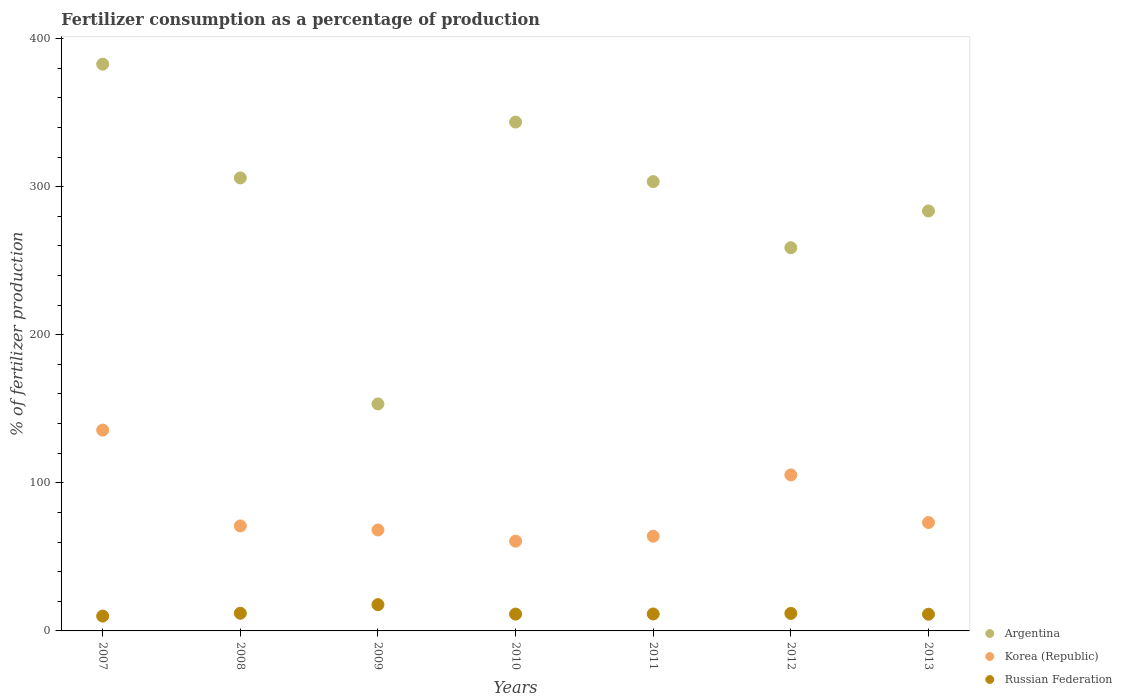How many different coloured dotlines are there?
Your response must be concise. 3. Is the number of dotlines equal to the number of legend labels?
Your answer should be compact. Yes. What is the percentage of fertilizers consumed in Argentina in 2010?
Offer a very short reply. 343.59. Across all years, what is the maximum percentage of fertilizers consumed in Russian Federation?
Offer a very short reply. 17.74. Across all years, what is the minimum percentage of fertilizers consumed in Russian Federation?
Your answer should be very brief. 10.02. In which year was the percentage of fertilizers consumed in Argentina minimum?
Keep it short and to the point. 2009. What is the total percentage of fertilizers consumed in Argentina in the graph?
Keep it short and to the point. 2031.15. What is the difference between the percentage of fertilizers consumed in Argentina in 2010 and that in 2013?
Offer a very short reply. 60. What is the difference between the percentage of fertilizers consumed in Korea (Republic) in 2011 and the percentage of fertilizers consumed in Russian Federation in 2008?
Make the answer very short. 52.02. What is the average percentage of fertilizers consumed in Korea (Republic) per year?
Keep it short and to the point. 82.53. In the year 2009, what is the difference between the percentage of fertilizers consumed in Korea (Republic) and percentage of fertilizers consumed in Argentina?
Give a very brief answer. -85.12. What is the ratio of the percentage of fertilizers consumed in Russian Federation in 2009 to that in 2010?
Provide a short and direct response. 1.56. Is the difference between the percentage of fertilizers consumed in Korea (Republic) in 2008 and 2013 greater than the difference between the percentage of fertilizers consumed in Argentina in 2008 and 2013?
Your answer should be compact. No. What is the difference between the highest and the second highest percentage of fertilizers consumed in Russian Federation?
Give a very brief answer. 5.81. What is the difference between the highest and the lowest percentage of fertilizers consumed in Korea (Republic)?
Your response must be concise. 74.99. Does the percentage of fertilizers consumed in Russian Federation monotonically increase over the years?
Your answer should be very brief. No. Is the percentage of fertilizers consumed in Korea (Republic) strictly greater than the percentage of fertilizers consumed in Argentina over the years?
Your answer should be very brief. No. Is the percentage of fertilizers consumed in Korea (Republic) strictly less than the percentage of fertilizers consumed in Argentina over the years?
Provide a short and direct response. Yes. How many dotlines are there?
Offer a terse response. 3. How many years are there in the graph?
Offer a terse response. 7. What is the difference between two consecutive major ticks on the Y-axis?
Your response must be concise. 100. Are the values on the major ticks of Y-axis written in scientific E-notation?
Ensure brevity in your answer.  No. Does the graph contain any zero values?
Give a very brief answer. No. Does the graph contain grids?
Give a very brief answer. No. How are the legend labels stacked?
Give a very brief answer. Vertical. What is the title of the graph?
Your response must be concise. Fertilizer consumption as a percentage of production. What is the label or title of the Y-axis?
Offer a terse response. % of fertilizer production. What is the % of fertilizer production of Argentina in 2007?
Provide a succinct answer. 382.69. What is the % of fertilizer production in Korea (Republic) in 2007?
Your answer should be compact. 135.6. What is the % of fertilizer production of Russian Federation in 2007?
Ensure brevity in your answer.  10.02. What is the % of fertilizer production of Argentina in 2008?
Ensure brevity in your answer.  305.88. What is the % of fertilizer production of Korea (Republic) in 2008?
Provide a succinct answer. 70.89. What is the % of fertilizer production of Russian Federation in 2008?
Your answer should be very brief. 11.93. What is the % of fertilizer production of Argentina in 2009?
Your answer should be compact. 153.28. What is the % of fertilizer production of Korea (Republic) in 2009?
Offer a very short reply. 68.16. What is the % of fertilizer production of Russian Federation in 2009?
Give a very brief answer. 17.74. What is the % of fertilizer production of Argentina in 2010?
Provide a short and direct response. 343.59. What is the % of fertilizer production of Korea (Republic) in 2010?
Keep it short and to the point. 60.61. What is the % of fertilizer production of Russian Federation in 2010?
Keep it short and to the point. 11.37. What is the % of fertilizer production in Argentina in 2011?
Your answer should be very brief. 303.39. What is the % of fertilizer production of Korea (Republic) in 2011?
Give a very brief answer. 63.95. What is the % of fertilizer production of Russian Federation in 2011?
Your answer should be very brief. 11.45. What is the % of fertilizer production in Argentina in 2012?
Keep it short and to the point. 258.74. What is the % of fertilizer production in Korea (Republic) in 2012?
Ensure brevity in your answer.  105.33. What is the % of fertilizer production in Russian Federation in 2012?
Provide a short and direct response. 11.83. What is the % of fertilizer production in Argentina in 2013?
Give a very brief answer. 283.59. What is the % of fertilizer production of Korea (Republic) in 2013?
Your answer should be very brief. 73.17. What is the % of fertilizer production of Russian Federation in 2013?
Provide a succinct answer. 11.27. Across all years, what is the maximum % of fertilizer production of Argentina?
Ensure brevity in your answer.  382.69. Across all years, what is the maximum % of fertilizer production in Korea (Republic)?
Offer a terse response. 135.6. Across all years, what is the maximum % of fertilizer production of Russian Federation?
Offer a very short reply. 17.74. Across all years, what is the minimum % of fertilizer production of Argentina?
Give a very brief answer. 153.28. Across all years, what is the minimum % of fertilizer production in Korea (Republic)?
Offer a very short reply. 60.61. Across all years, what is the minimum % of fertilizer production of Russian Federation?
Offer a terse response. 10.02. What is the total % of fertilizer production of Argentina in the graph?
Your answer should be very brief. 2031.15. What is the total % of fertilizer production in Korea (Republic) in the graph?
Ensure brevity in your answer.  577.71. What is the total % of fertilizer production in Russian Federation in the graph?
Make the answer very short. 85.61. What is the difference between the % of fertilizer production in Argentina in 2007 and that in 2008?
Your response must be concise. 76.81. What is the difference between the % of fertilizer production in Korea (Republic) in 2007 and that in 2008?
Your response must be concise. 64.71. What is the difference between the % of fertilizer production in Russian Federation in 2007 and that in 2008?
Ensure brevity in your answer.  -1.9. What is the difference between the % of fertilizer production of Argentina in 2007 and that in 2009?
Your answer should be very brief. 229.41. What is the difference between the % of fertilizer production of Korea (Republic) in 2007 and that in 2009?
Offer a terse response. 67.44. What is the difference between the % of fertilizer production in Russian Federation in 2007 and that in 2009?
Your response must be concise. -7.72. What is the difference between the % of fertilizer production in Argentina in 2007 and that in 2010?
Ensure brevity in your answer.  39.1. What is the difference between the % of fertilizer production of Korea (Republic) in 2007 and that in 2010?
Your answer should be very brief. 74.99. What is the difference between the % of fertilizer production of Russian Federation in 2007 and that in 2010?
Your answer should be compact. -1.35. What is the difference between the % of fertilizer production in Argentina in 2007 and that in 2011?
Your answer should be compact. 79.3. What is the difference between the % of fertilizer production of Korea (Republic) in 2007 and that in 2011?
Keep it short and to the point. 71.65. What is the difference between the % of fertilizer production in Russian Federation in 2007 and that in 2011?
Provide a short and direct response. -1.42. What is the difference between the % of fertilizer production of Argentina in 2007 and that in 2012?
Your answer should be very brief. 123.95. What is the difference between the % of fertilizer production of Korea (Republic) in 2007 and that in 2012?
Your response must be concise. 30.27. What is the difference between the % of fertilizer production of Russian Federation in 2007 and that in 2012?
Offer a very short reply. -1.81. What is the difference between the % of fertilizer production in Argentina in 2007 and that in 2013?
Offer a very short reply. 99.1. What is the difference between the % of fertilizer production of Korea (Republic) in 2007 and that in 2013?
Ensure brevity in your answer.  62.42. What is the difference between the % of fertilizer production of Russian Federation in 2007 and that in 2013?
Ensure brevity in your answer.  -1.24. What is the difference between the % of fertilizer production in Argentina in 2008 and that in 2009?
Ensure brevity in your answer.  152.6. What is the difference between the % of fertilizer production in Korea (Republic) in 2008 and that in 2009?
Ensure brevity in your answer.  2.73. What is the difference between the % of fertilizer production in Russian Federation in 2008 and that in 2009?
Offer a terse response. -5.81. What is the difference between the % of fertilizer production in Argentina in 2008 and that in 2010?
Provide a short and direct response. -37.71. What is the difference between the % of fertilizer production of Korea (Republic) in 2008 and that in 2010?
Provide a succinct answer. 10.28. What is the difference between the % of fertilizer production of Russian Federation in 2008 and that in 2010?
Your answer should be compact. 0.56. What is the difference between the % of fertilizer production in Argentina in 2008 and that in 2011?
Your answer should be very brief. 2.49. What is the difference between the % of fertilizer production of Korea (Republic) in 2008 and that in 2011?
Keep it short and to the point. 6.94. What is the difference between the % of fertilizer production of Russian Federation in 2008 and that in 2011?
Give a very brief answer. 0.48. What is the difference between the % of fertilizer production in Argentina in 2008 and that in 2012?
Your answer should be compact. 47.14. What is the difference between the % of fertilizer production of Korea (Republic) in 2008 and that in 2012?
Keep it short and to the point. -34.44. What is the difference between the % of fertilizer production in Russian Federation in 2008 and that in 2012?
Your response must be concise. 0.1. What is the difference between the % of fertilizer production in Argentina in 2008 and that in 2013?
Keep it short and to the point. 22.29. What is the difference between the % of fertilizer production of Korea (Republic) in 2008 and that in 2013?
Make the answer very short. -2.28. What is the difference between the % of fertilizer production in Russian Federation in 2008 and that in 2013?
Offer a terse response. 0.66. What is the difference between the % of fertilizer production of Argentina in 2009 and that in 2010?
Ensure brevity in your answer.  -190.31. What is the difference between the % of fertilizer production in Korea (Republic) in 2009 and that in 2010?
Your response must be concise. 7.55. What is the difference between the % of fertilizer production of Russian Federation in 2009 and that in 2010?
Keep it short and to the point. 6.37. What is the difference between the % of fertilizer production in Argentina in 2009 and that in 2011?
Offer a very short reply. -150.11. What is the difference between the % of fertilizer production in Korea (Republic) in 2009 and that in 2011?
Make the answer very short. 4.21. What is the difference between the % of fertilizer production of Russian Federation in 2009 and that in 2011?
Make the answer very short. 6.3. What is the difference between the % of fertilizer production of Argentina in 2009 and that in 2012?
Ensure brevity in your answer.  -105.46. What is the difference between the % of fertilizer production in Korea (Republic) in 2009 and that in 2012?
Give a very brief answer. -37.17. What is the difference between the % of fertilizer production in Russian Federation in 2009 and that in 2012?
Ensure brevity in your answer.  5.91. What is the difference between the % of fertilizer production in Argentina in 2009 and that in 2013?
Your response must be concise. -130.31. What is the difference between the % of fertilizer production of Korea (Republic) in 2009 and that in 2013?
Keep it short and to the point. -5.01. What is the difference between the % of fertilizer production of Russian Federation in 2009 and that in 2013?
Offer a terse response. 6.47. What is the difference between the % of fertilizer production of Argentina in 2010 and that in 2011?
Give a very brief answer. 40.2. What is the difference between the % of fertilizer production in Korea (Republic) in 2010 and that in 2011?
Make the answer very short. -3.34. What is the difference between the % of fertilizer production of Russian Federation in 2010 and that in 2011?
Provide a succinct answer. -0.08. What is the difference between the % of fertilizer production in Argentina in 2010 and that in 2012?
Provide a succinct answer. 84.85. What is the difference between the % of fertilizer production in Korea (Republic) in 2010 and that in 2012?
Provide a succinct answer. -44.72. What is the difference between the % of fertilizer production of Russian Federation in 2010 and that in 2012?
Keep it short and to the point. -0.46. What is the difference between the % of fertilizer production of Argentina in 2010 and that in 2013?
Provide a short and direct response. 60. What is the difference between the % of fertilizer production in Korea (Republic) in 2010 and that in 2013?
Give a very brief answer. -12.56. What is the difference between the % of fertilizer production of Russian Federation in 2010 and that in 2013?
Keep it short and to the point. 0.1. What is the difference between the % of fertilizer production in Argentina in 2011 and that in 2012?
Provide a succinct answer. 44.65. What is the difference between the % of fertilizer production of Korea (Republic) in 2011 and that in 2012?
Offer a terse response. -41.39. What is the difference between the % of fertilizer production in Russian Federation in 2011 and that in 2012?
Give a very brief answer. -0.39. What is the difference between the % of fertilizer production of Argentina in 2011 and that in 2013?
Keep it short and to the point. 19.8. What is the difference between the % of fertilizer production of Korea (Republic) in 2011 and that in 2013?
Your response must be concise. -9.23. What is the difference between the % of fertilizer production of Russian Federation in 2011 and that in 2013?
Make the answer very short. 0.18. What is the difference between the % of fertilizer production of Argentina in 2012 and that in 2013?
Make the answer very short. -24.85. What is the difference between the % of fertilizer production of Korea (Republic) in 2012 and that in 2013?
Provide a short and direct response. 32.16. What is the difference between the % of fertilizer production in Russian Federation in 2012 and that in 2013?
Your response must be concise. 0.56. What is the difference between the % of fertilizer production in Argentina in 2007 and the % of fertilizer production in Korea (Republic) in 2008?
Offer a very short reply. 311.8. What is the difference between the % of fertilizer production of Argentina in 2007 and the % of fertilizer production of Russian Federation in 2008?
Provide a succinct answer. 370.76. What is the difference between the % of fertilizer production of Korea (Republic) in 2007 and the % of fertilizer production of Russian Federation in 2008?
Your answer should be compact. 123.67. What is the difference between the % of fertilizer production in Argentina in 2007 and the % of fertilizer production in Korea (Republic) in 2009?
Your answer should be compact. 314.53. What is the difference between the % of fertilizer production in Argentina in 2007 and the % of fertilizer production in Russian Federation in 2009?
Offer a terse response. 364.95. What is the difference between the % of fertilizer production of Korea (Republic) in 2007 and the % of fertilizer production of Russian Federation in 2009?
Make the answer very short. 117.86. What is the difference between the % of fertilizer production of Argentina in 2007 and the % of fertilizer production of Korea (Republic) in 2010?
Ensure brevity in your answer.  322.08. What is the difference between the % of fertilizer production in Argentina in 2007 and the % of fertilizer production in Russian Federation in 2010?
Your response must be concise. 371.32. What is the difference between the % of fertilizer production of Korea (Republic) in 2007 and the % of fertilizer production of Russian Federation in 2010?
Your answer should be compact. 124.23. What is the difference between the % of fertilizer production in Argentina in 2007 and the % of fertilizer production in Korea (Republic) in 2011?
Keep it short and to the point. 318.74. What is the difference between the % of fertilizer production in Argentina in 2007 and the % of fertilizer production in Russian Federation in 2011?
Ensure brevity in your answer.  371.24. What is the difference between the % of fertilizer production in Korea (Republic) in 2007 and the % of fertilizer production in Russian Federation in 2011?
Offer a terse response. 124.15. What is the difference between the % of fertilizer production in Argentina in 2007 and the % of fertilizer production in Korea (Republic) in 2012?
Give a very brief answer. 277.36. What is the difference between the % of fertilizer production in Argentina in 2007 and the % of fertilizer production in Russian Federation in 2012?
Offer a very short reply. 370.86. What is the difference between the % of fertilizer production in Korea (Republic) in 2007 and the % of fertilizer production in Russian Federation in 2012?
Your response must be concise. 123.77. What is the difference between the % of fertilizer production in Argentina in 2007 and the % of fertilizer production in Korea (Republic) in 2013?
Your answer should be compact. 309.51. What is the difference between the % of fertilizer production in Argentina in 2007 and the % of fertilizer production in Russian Federation in 2013?
Keep it short and to the point. 371.42. What is the difference between the % of fertilizer production of Korea (Republic) in 2007 and the % of fertilizer production of Russian Federation in 2013?
Provide a succinct answer. 124.33. What is the difference between the % of fertilizer production of Argentina in 2008 and the % of fertilizer production of Korea (Republic) in 2009?
Make the answer very short. 237.72. What is the difference between the % of fertilizer production of Argentina in 2008 and the % of fertilizer production of Russian Federation in 2009?
Make the answer very short. 288.14. What is the difference between the % of fertilizer production of Korea (Republic) in 2008 and the % of fertilizer production of Russian Federation in 2009?
Provide a succinct answer. 53.15. What is the difference between the % of fertilizer production in Argentina in 2008 and the % of fertilizer production in Korea (Republic) in 2010?
Provide a short and direct response. 245.27. What is the difference between the % of fertilizer production of Argentina in 2008 and the % of fertilizer production of Russian Federation in 2010?
Your answer should be very brief. 294.51. What is the difference between the % of fertilizer production in Korea (Republic) in 2008 and the % of fertilizer production in Russian Federation in 2010?
Provide a succinct answer. 59.52. What is the difference between the % of fertilizer production of Argentina in 2008 and the % of fertilizer production of Korea (Republic) in 2011?
Offer a terse response. 241.93. What is the difference between the % of fertilizer production in Argentina in 2008 and the % of fertilizer production in Russian Federation in 2011?
Keep it short and to the point. 294.43. What is the difference between the % of fertilizer production in Korea (Republic) in 2008 and the % of fertilizer production in Russian Federation in 2011?
Provide a succinct answer. 59.44. What is the difference between the % of fertilizer production in Argentina in 2008 and the % of fertilizer production in Korea (Republic) in 2012?
Your answer should be very brief. 200.55. What is the difference between the % of fertilizer production in Argentina in 2008 and the % of fertilizer production in Russian Federation in 2012?
Your answer should be compact. 294.05. What is the difference between the % of fertilizer production of Korea (Republic) in 2008 and the % of fertilizer production of Russian Federation in 2012?
Your answer should be very brief. 59.06. What is the difference between the % of fertilizer production of Argentina in 2008 and the % of fertilizer production of Korea (Republic) in 2013?
Offer a terse response. 232.71. What is the difference between the % of fertilizer production in Argentina in 2008 and the % of fertilizer production in Russian Federation in 2013?
Your answer should be compact. 294.61. What is the difference between the % of fertilizer production in Korea (Republic) in 2008 and the % of fertilizer production in Russian Federation in 2013?
Provide a succinct answer. 59.62. What is the difference between the % of fertilizer production in Argentina in 2009 and the % of fertilizer production in Korea (Republic) in 2010?
Ensure brevity in your answer.  92.67. What is the difference between the % of fertilizer production in Argentina in 2009 and the % of fertilizer production in Russian Federation in 2010?
Provide a short and direct response. 141.91. What is the difference between the % of fertilizer production of Korea (Republic) in 2009 and the % of fertilizer production of Russian Federation in 2010?
Give a very brief answer. 56.79. What is the difference between the % of fertilizer production of Argentina in 2009 and the % of fertilizer production of Korea (Republic) in 2011?
Ensure brevity in your answer.  89.33. What is the difference between the % of fertilizer production of Argentina in 2009 and the % of fertilizer production of Russian Federation in 2011?
Give a very brief answer. 141.83. What is the difference between the % of fertilizer production of Korea (Republic) in 2009 and the % of fertilizer production of Russian Federation in 2011?
Your answer should be compact. 56.71. What is the difference between the % of fertilizer production in Argentina in 2009 and the % of fertilizer production in Korea (Republic) in 2012?
Ensure brevity in your answer.  47.95. What is the difference between the % of fertilizer production of Argentina in 2009 and the % of fertilizer production of Russian Federation in 2012?
Ensure brevity in your answer.  141.45. What is the difference between the % of fertilizer production in Korea (Republic) in 2009 and the % of fertilizer production in Russian Federation in 2012?
Offer a terse response. 56.33. What is the difference between the % of fertilizer production in Argentina in 2009 and the % of fertilizer production in Korea (Republic) in 2013?
Your answer should be compact. 80.1. What is the difference between the % of fertilizer production in Argentina in 2009 and the % of fertilizer production in Russian Federation in 2013?
Make the answer very short. 142.01. What is the difference between the % of fertilizer production of Korea (Republic) in 2009 and the % of fertilizer production of Russian Federation in 2013?
Ensure brevity in your answer.  56.89. What is the difference between the % of fertilizer production in Argentina in 2010 and the % of fertilizer production in Korea (Republic) in 2011?
Ensure brevity in your answer.  279.64. What is the difference between the % of fertilizer production in Argentina in 2010 and the % of fertilizer production in Russian Federation in 2011?
Offer a very short reply. 332.14. What is the difference between the % of fertilizer production of Korea (Republic) in 2010 and the % of fertilizer production of Russian Federation in 2011?
Keep it short and to the point. 49.16. What is the difference between the % of fertilizer production in Argentina in 2010 and the % of fertilizer production in Korea (Republic) in 2012?
Offer a terse response. 238.26. What is the difference between the % of fertilizer production of Argentina in 2010 and the % of fertilizer production of Russian Federation in 2012?
Provide a short and direct response. 331.76. What is the difference between the % of fertilizer production of Korea (Republic) in 2010 and the % of fertilizer production of Russian Federation in 2012?
Offer a terse response. 48.78. What is the difference between the % of fertilizer production in Argentina in 2010 and the % of fertilizer production in Korea (Republic) in 2013?
Your answer should be compact. 270.41. What is the difference between the % of fertilizer production in Argentina in 2010 and the % of fertilizer production in Russian Federation in 2013?
Make the answer very short. 332.32. What is the difference between the % of fertilizer production of Korea (Republic) in 2010 and the % of fertilizer production of Russian Federation in 2013?
Ensure brevity in your answer.  49.34. What is the difference between the % of fertilizer production of Argentina in 2011 and the % of fertilizer production of Korea (Republic) in 2012?
Make the answer very short. 198.06. What is the difference between the % of fertilizer production in Argentina in 2011 and the % of fertilizer production in Russian Federation in 2012?
Keep it short and to the point. 291.56. What is the difference between the % of fertilizer production of Korea (Republic) in 2011 and the % of fertilizer production of Russian Federation in 2012?
Give a very brief answer. 52.12. What is the difference between the % of fertilizer production of Argentina in 2011 and the % of fertilizer production of Korea (Republic) in 2013?
Your response must be concise. 230.22. What is the difference between the % of fertilizer production of Argentina in 2011 and the % of fertilizer production of Russian Federation in 2013?
Your response must be concise. 292.12. What is the difference between the % of fertilizer production in Korea (Republic) in 2011 and the % of fertilizer production in Russian Federation in 2013?
Give a very brief answer. 52.68. What is the difference between the % of fertilizer production of Argentina in 2012 and the % of fertilizer production of Korea (Republic) in 2013?
Offer a very short reply. 185.57. What is the difference between the % of fertilizer production of Argentina in 2012 and the % of fertilizer production of Russian Federation in 2013?
Your response must be concise. 247.47. What is the difference between the % of fertilizer production of Korea (Republic) in 2012 and the % of fertilizer production of Russian Federation in 2013?
Ensure brevity in your answer.  94.06. What is the average % of fertilizer production of Argentina per year?
Provide a short and direct response. 290.16. What is the average % of fertilizer production in Korea (Republic) per year?
Make the answer very short. 82.53. What is the average % of fertilizer production of Russian Federation per year?
Keep it short and to the point. 12.23. In the year 2007, what is the difference between the % of fertilizer production in Argentina and % of fertilizer production in Korea (Republic)?
Give a very brief answer. 247.09. In the year 2007, what is the difference between the % of fertilizer production in Argentina and % of fertilizer production in Russian Federation?
Offer a terse response. 372.66. In the year 2007, what is the difference between the % of fertilizer production in Korea (Republic) and % of fertilizer production in Russian Federation?
Offer a terse response. 125.57. In the year 2008, what is the difference between the % of fertilizer production in Argentina and % of fertilizer production in Korea (Republic)?
Your answer should be compact. 234.99. In the year 2008, what is the difference between the % of fertilizer production in Argentina and % of fertilizer production in Russian Federation?
Your answer should be very brief. 293.95. In the year 2008, what is the difference between the % of fertilizer production in Korea (Republic) and % of fertilizer production in Russian Federation?
Ensure brevity in your answer.  58.96. In the year 2009, what is the difference between the % of fertilizer production in Argentina and % of fertilizer production in Korea (Republic)?
Offer a terse response. 85.12. In the year 2009, what is the difference between the % of fertilizer production of Argentina and % of fertilizer production of Russian Federation?
Make the answer very short. 135.54. In the year 2009, what is the difference between the % of fertilizer production of Korea (Republic) and % of fertilizer production of Russian Federation?
Your answer should be very brief. 50.42. In the year 2010, what is the difference between the % of fertilizer production in Argentina and % of fertilizer production in Korea (Republic)?
Offer a very short reply. 282.98. In the year 2010, what is the difference between the % of fertilizer production in Argentina and % of fertilizer production in Russian Federation?
Offer a very short reply. 332.22. In the year 2010, what is the difference between the % of fertilizer production in Korea (Republic) and % of fertilizer production in Russian Federation?
Give a very brief answer. 49.24. In the year 2011, what is the difference between the % of fertilizer production in Argentina and % of fertilizer production in Korea (Republic)?
Your response must be concise. 239.44. In the year 2011, what is the difference between the % of fertilizer production in Argentina and % of fertilizer production in Russian Federation?
Offer a very short reply. 291.94. In the year 2011, what is the difference between the % of fertilizer production of Korea (Republic) and % of fertilizer production of Russian Federation?
Your answer should be very brief. 52.5. In the year 2012, what is the difference between the % of fertilizer production in Argentina and % of fertilizer production in Korea (Republic)?
Give a very brief answer. 153.41. In the year 2012, what is the difference between the % of fertilizer production in Argentina and % of fertilizer production in Russian Federation?
Your answer should be compact. 246.91. In the year 2012, what is the difference between the % of fertilizer production in Korea (Republic) and % of fertilizer production in Russian Federation?
Your response must be concise. 93.5. In the year 2013, what is the difference between the % of fertilizer production in Argentina and % of fertilizer production in Korea (Republic)?
Your response must be concise. 210.41. In the year 2013, what is the difference between the % of fertilizer production in Argentina and % of fertilizer production in Russian Federation?
Ensure brevity in your answer.  272.32. In the year 2013, what is the difference between the % of fertilizer production in Korea (Republic) and % of fertilizer production in Russian Federation?
Provide a short and direct response. 61.91. What is the ratio of the % of fertilizer production of Argentina in 2007 to that in 2008?
Give a very brief answer. 1.25. What is the ratio of the % of fertilizer production of Korea (Republic) in 2007 to that in 2008?
Make the answer very short. 1.91. What is the ratio of the % of fertilizer production of Russian Federation in 2007 to that in 2008?
Offer a terse response. 0.84. What is the ratio of the % of fertilizer production in Argentina in 2007 to that in 2009?
Offer a terse response. 2.5. What is the ratio of the % of fertilizer production in Korea (Republic) in 2007 to that in 2009?
Your answer should be compact. 1.99. What is the ratio of the % of fertilizer production of Russian Federation in 2007 to that in 2009?
Your answer should be very brief. 0.56. What is the ratio of the % of fertilizer production in Argentina in 2007 to that in 2010?
Make the answer very short. 1.11. What is the ratio of the % of fertilizer production of Korea (Republic) in 2007 to that in 2010?
Your response must be concise. 2.24. What is the ratio of the % of fertilizer production in Russian Federation in 2007 to that in 2010?
Ensure brevity in your answer.  0.88. What is the ratio of the % of fertilizer production of Argentina in 2007 to that in 2011?
Make the answer very short. 1.26. What is the ratio of the % of fertilizer production of Korea (Republic) in 2007 to that in 2011?
Provide a succinct answer. 2.12. What is the ratio of the % of fertilizer production in Russian Federation in 2007 to that in 2011?
Provide a succinct answer. 0.88. What is the ratio of the % of fertilizer production in Argentina in 2007 to that in 2012?
Provide a succinct answer. 1.48. What is the ratio of the % of fertilizer production in Korea (Republic) in 2007 to that in 2012?
Your response must be concise. 1.29. What is the ratio of the % of fertilizer production in Russian Federation in 2007 to that in 2012?
Keep it short and to the point. 0.85. What is the ratio of the % of fertilizer production of Argentina in 2007 to that in 2013?
Offer a very short reply. 1.35. What is the ratio of the % of fertilizer production in Korea (Republic) in 2007 to that in 2013?
Ensure brevity in your answer.  1.85. What is the ratio of the % of fertilizer production of Russian Federation in 2007 to that in 2013?
Keep it short and to the point. 0.89. What is the ratio of the % of fertilizer production in Argentina in 2008 to that in 2009?
Make the answer very short. 2. What is the ratio of the % of fertilizer production of Korea (Republic) in 2008 to that in 2009?
Offer a very short reply. 1.04. What is the ratio of the % of fertilizer production of Russian Federation in 2008 to that in 2009?
Provide a short and direct response. 0.67. What is the ratio of the % of fertilizer production in Argentina in 2008 to that in 2010?
Make the answer very short. 0.89. What is the ratio of the % of fertilizer production of Korea (Republic) in 2008 to that in 2010?
Offer a very short reply. 1.17. What is the ratio of the % of fertilizer production of Russian Federation in 2008 to that in 2010?
Give a very brief answer. 1.05. What is the ratio of the % of fertilizer production of Argentina in 2008 to that in 2011?
Ensure brevity in your answer.  1.01. What is the ratio of the % of fertilizer production of Korea (Republic) in 2008 to that in 2011?
Your answer should be compact. 1.11. What is the ratio of the % of fertilizer production in Russian Federation in 2008 to that in 2011?
Provide a short and direct response. 1.04. What is the ratio of the % of fertilizer production in Argentina in 2008 to that in 2012?
Your answer should be very brief. 1.18. What is the ratio of the % of fertilizer production of Korea (Republic) in 2008 to that in 2012?
Keep it short and to the point. 0.67. What is the ratio of the % of fertilizer production in Russian Federation in 2008 to that in 2012?
Ensure brevity in your answer.  1.01. What is the ratio of the % of fertilizer production of Argentina in 2008 to that in 2013?
Your answer should be compact. 1.08. What is the ratio of the % of fertilizer production in Korea (Republic) in 2008 to that in 2013?
Provide a succinct answer. 0.97. What is the ratio of the % of fertilizer production in Russian Federation in 2008 to that in 2013?
Provide a short and direct response. 1.06. What is the ratio of the % of fertilizer production of Argentina in 2009 to that in 2010?
Provide a short and direct response. 0.45. What is the ratio of the % of fertilizer production in Korea (Republic) in 2009 to that in 2010?
Give a very brief answer. 1.12. What is the ratio of the % of fertilizer production of Russian Federation in 2009 to that in 2010?
Keep it short and to the point. 1.56. What is the ratio of the % of fertilizer production in Argentina in 2009 to that in 2011?
Offer a very short reply. 0.51. What is the ratio of the % of fertilizer production of Korea (Republic) in 2009 to that in 2011?
Provide a succinct answer. 1.07. What is the ratio of the % of fertilizer production of Russian Federation in 2009 to that in 2011?
Your response must be concise. 1.55. What is the ratio of the % of fertilizer production in Argentina in 2009 to that in 2012?
Offer a terse response. 0.59. What is the ratio of the % of fertilizer production of Korea (Republic) in 2009 to that in 2012?
Make the answer very short. 0.65. What is the ratio of the % of fertilizer production of Russian Federation in 2009 to that in 2012?
Offer a terse response. 1.5. What is the ratio of the % of fertilizer production in Argentina in 2009 to that in 2013?
Your answer should be compact. 0.54. What is the ratio of the % of fertilizer production in Korea (Republic) in 2009 to that in 2013?
Ensure brevity in your answer.  0.93. What is the ratio of the % of fertilizer production of Russian Federation in 2009 to that in 2013?
Give a very brief answer. 1.57. What is the ratio of the % of fertilizer production of Argentina in 2010 to that in 2011?
Offer a very short reply. 1.13. What is the ratio of the % of fertilizer production of Korea (Republic) in 2010 to that in 2011?
Make the answer very short. 0.95. What is the ratio of the % of fertilizer production of Russian Federation in 2010 to that in 2011?
Offer a very short reply. 0.99. What is the ratio of the % of fertilizer production of Argentina in 2010 to that in 2012?
Keep it short and to the point. 1.33. What is the ratio of the % of fertilizer production of Korea (Republic) in 2010 to that in 2012?
Your response must be concise. 0.58. What is the ratio of the % of fertilizer production of Argentina in 2010 to that in 2013?
Your answer should be very brief. 1.21. What is the ratio of the % of fertilizer production of Korea (Republic) in 2010 to that in 2013?
Offer a terse response. 0.83. What is the ratio of the % of fertilizer production of Russian Federation in 2010 to that in 2013?
Your response must be concise. 1.01. What is the ratio of the % of fertilizer production in Argentina in 2011 to that in 2012?
Offer a terse response. 1.17. What is the ratio of the % of fertilizer production in Korea (Republic) in 2011 to that in 2012?
Provide a succinct answer. 0.61. What is the ratio of the % of fertilizer production in Russian Federation in 2011 to that in 2012?
Your answer should be very brief. 0.97. What is the ratio of the % of fertilizer production in Argentina in 2011 to that in 2013?
Ensure brevity in your answer.  1.07. What is the ratio of the % of fertilizer production of Korea (Republic) in 2011 to that in 2013?
Offer a very short reply. 0.87. What is the ratio of the % of fertilizer production in Russian Federation in 2011 to that in 2013?
Give a very brief answer. 1.02. What is the ratio of the % of fertilizer production of Argentina in 2012 to that in 2013?
Provide a succinct answer. 0.91. What is the ratio of the % of fertilizer production of Korea (Republic) in 2012 to that in 2013?
Provide a succinct answer. 1.44. What is the ratio of the % of fertilizer production in Russian Federation in 2012 to that in 2013?
Offer a terse response. 1.05. What is the difference between the highest and the second highest % of fertilizer production in Argentina?
Keep it short and to the point. 39.1. What is the difference between the highest and the second highest % of fertilizer production in Korea (Republic)?
Provide a succinct answer. 30.27. What is the difference between the highest and the second highest % of fertilizer production of Russian Federation?
Your answer should be very brief. 5.81. What is the difference between the highest and the lowest % of fertilizer production of Argentina?
Make the answer very short. 229.41. What is the difference between the highest and the lowest % of fertilizer production of Korea (Republic)?
Provide a short and direct response. 74.99. What is the difference between the highest and the lowest % of fertilizer production of Russian Federation?
Your answer should be very brief. 7.72. 